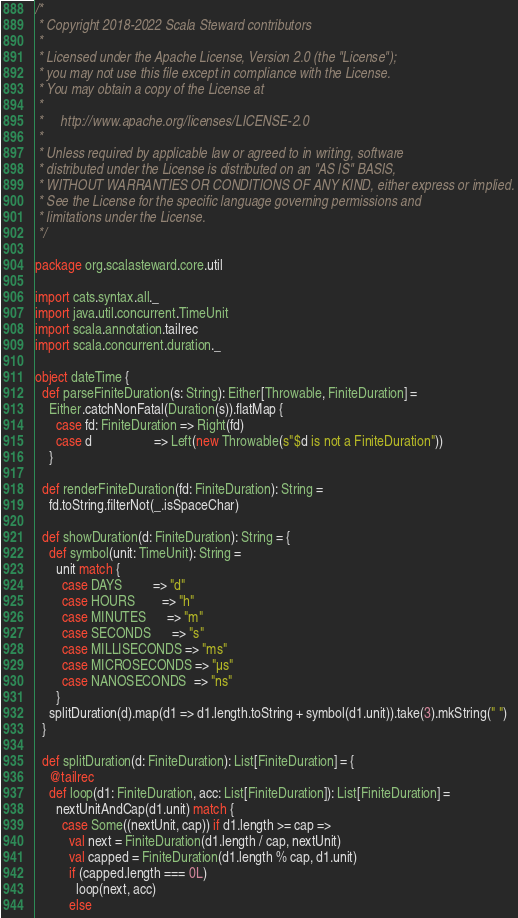<code> <loc_0><loc_0><loc_500><loc_500><_Scala_>/*
 * Copyright 2018-2022 Scala Steward contributors
 *
 * Licensed under the Apache License, Version 2.0 (the "License");
 * you may not use this file except in compliance with the License.
 * You may obtain a copy of the License at
 *
 *     http://www.apache.org/licenses/LICENSE-2.0
 *
 * Unless required by applicable law or agreed to in writing, software
 * distributed under the License is distributed on an "AS IS" BASIS,
 * WITHOUT WARRANTIES OR CONDITIONS OF ANY KIND, either express or implied.
 * See the License for the specific language governing permissions and
 * limitations under the License.
 */

package org.scalasteward.core.util

import cats.syntax.all._
import java.util.concurrent.TimeUnit
import scala.annotation.tailrec
import scala.concurrent.duration._

object dateTime {
  def parseFiniteDuration(s: String): Either[Throwable, FiniteDuration] =
    Either.catchNonFatal(Duration(s)).flatMap {
      case fd: FiniteDuration => Right(fd)
      case d                  => Left(new Throwable(s"$d is not a FiniteDuration"))
    }

  def renderFiniteDuration(fd: FiniteDuration): String =
    fd.toString.filterNot(_.isSpaceChar)

  def showDuration(d: FiniteDuration): String = {
    def symbol(unit: TimeUnit): String =
      unit match {
        case DAYS         => "d"
        case HOURS        => "h"
        case MINUTES      => "m"
        case SECONDS      => "s"
        case MILLISECONDS => "ms"
        case MICROSECONDS => "µs"
        case NANOSECONDS  => "ns"
      }
    splitDuration(d).map(d1 => d1.length.toString + symbol(d1.unit)).take(3).mkString(" ")
  }

  def splitDuration(d: FiniteDuration): List[FiniteDuration] = {
    @tailrec
    def loop(d1: FiniteDuration, acc: List[FiniteDuration]): List[FiniteDuration] =
      nextUnitAndCap(d1.unit) match {
        case Some((nextUnit, cap)) if d1.length >= cap =>
          val next = FiniteDuration(d1.length / cap, nextUnit)
          val capped = FiniteDuration(d1.length % cap, d1.unit)
          if (capped.length === 0L)
            loop(next, acc)
          else</code> 